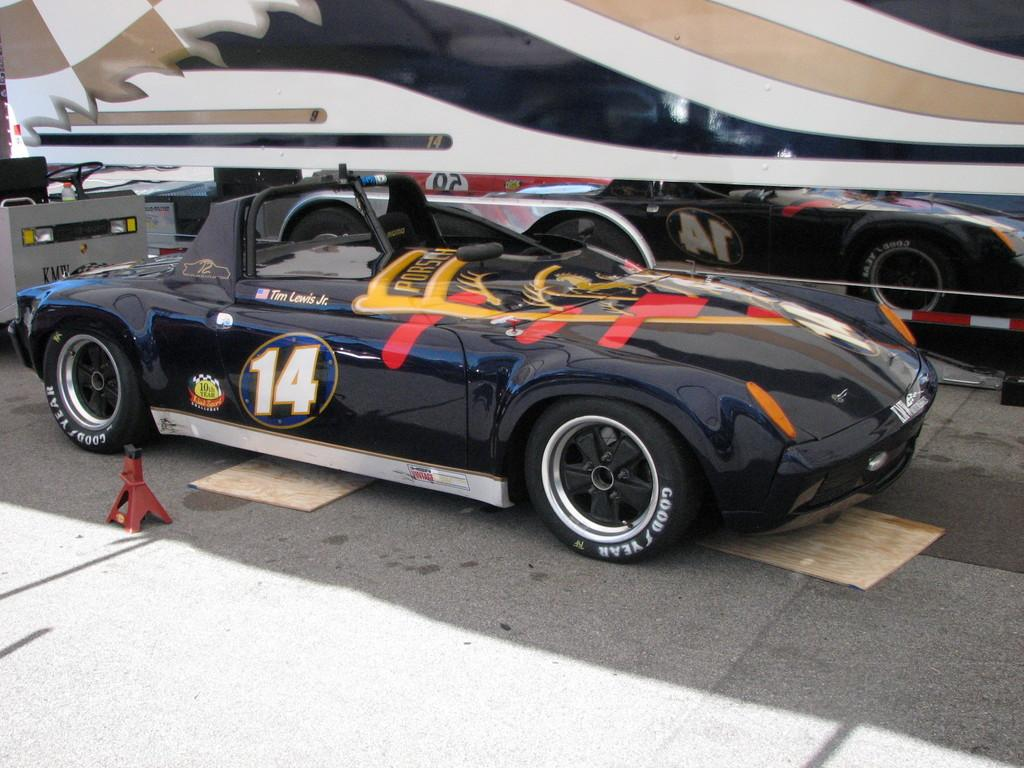<image>
Present a compact description of the photo's key features. A black car with orange and red accents is numbered 14. 